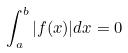Convert formula to latex. <formula><loc_0><loc_0><loc_500><loc_500>\int _ { a } ^ { b } | f ( x ) | d x = 0</formula> 